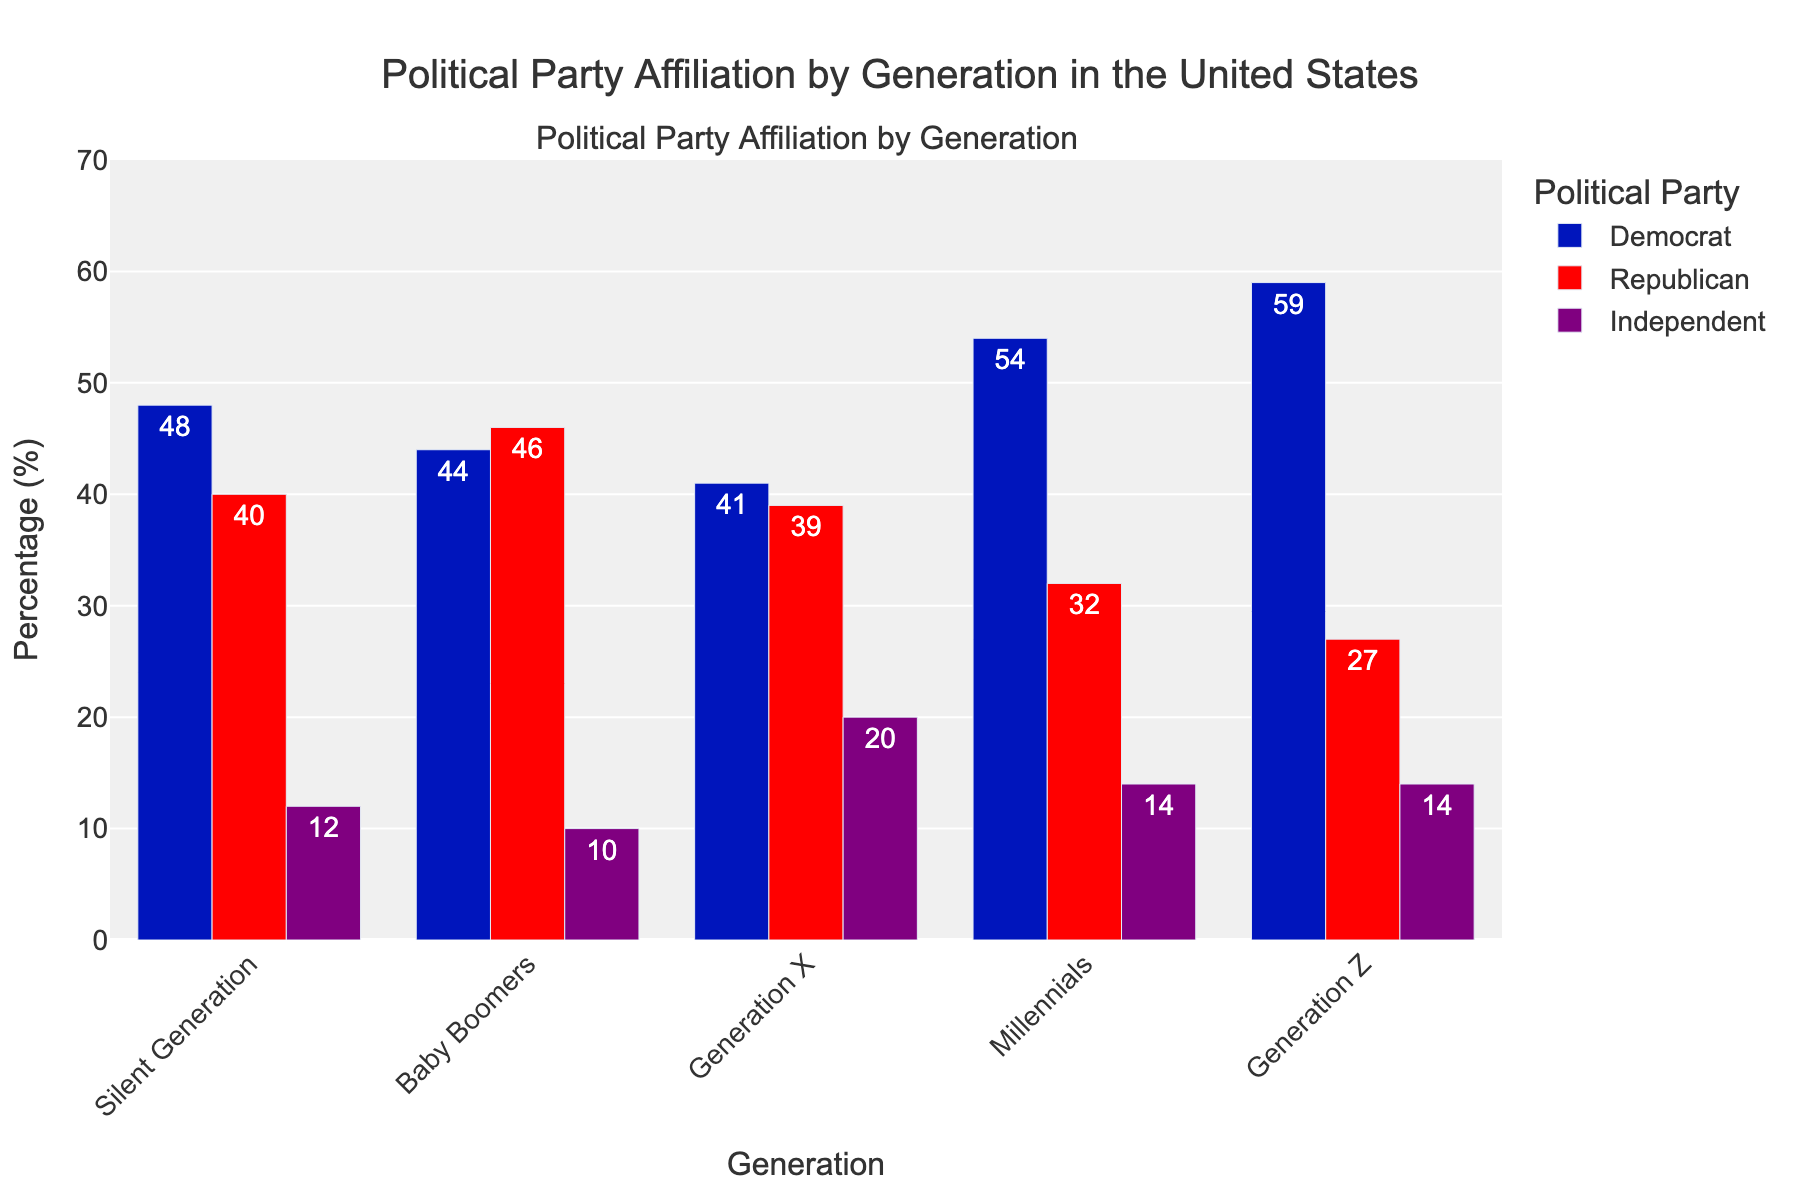What percentage of Millennials identified as Democrats? To find the percentage of Millennials who identified as Democrats, refer to the "Democrat" bar for the "Millennials" category. The bar has a height labeled with the percentage value to its nearest integer.
Answer: 54% How does the percentage of Generation X that identified as Republicans compare to the Silent Generation? Compare the height of the "Republican" bars for both Generation X and the Silent Generation. The Generation X bar has a height of 39%, and the Silent Generation bar has a height of 40%. Therefore, the Silent Generation has a 1% higher percentage.
Answer: Silent Generation has 1% more What's the sum of the percentages of Independents across all generations? Add the values of the "Independent" bars for each generation: 12% (Silent Generation) + 10% (Baby Boomers) + 20% (Generation X) + 14% (Millennials) + 14% (Generation Z). Calculating these gives a total of 70%.
Answer: 70% Which generation has the largest gap between the percentage of Democrats and Republicans? Calculate the absolute differences for each generation: Silent Generation (48% - 40% = 8%), Baby Boomers (46% - 44% = 2%), Generation X (41% - 39% = 2%), Millennials (54% - 32% = 22%), Generation Z (59% - 27% = 32%). Generation Z has the largest gap.
Answer: Generation Z How many generations have a higher percentage of Republicans than Democrats? Compare the "Republican" and "Democrat" bars for all generations: Silent Generation (48% vs. 40%), Baby Boomers (44% vs. 46%), Generation X (41% vs. 39%), Millennials (54% vs. 32%), Generation Z (59% vs. 27%). Only Baby Boomers exceed in Republicans over Democrats.
Answer: One generation What is the average percentage of those who identified as Independents across all generations? To find the average, sum the percentages of Independents for all generations (12% + 10% + 20% + 14% + 14%) and divide by the number of generations (5). The sum is 70%, and the average is 70% / 5 = 14%.
Answer: 14% Which political affiliation has the highest cumulative percentage across all generations? Sum the percentages for each political affiliation: Democrats (48 + 44 + 41 + 54 + 59 = 246), Republicans (40 + 46 + 39 + 32 + 27 = 184), Independents (12 + 10 + 20 + 14 + 14 = 70). Democrats have the highest cumulative percentage.
Answer: Democrats 